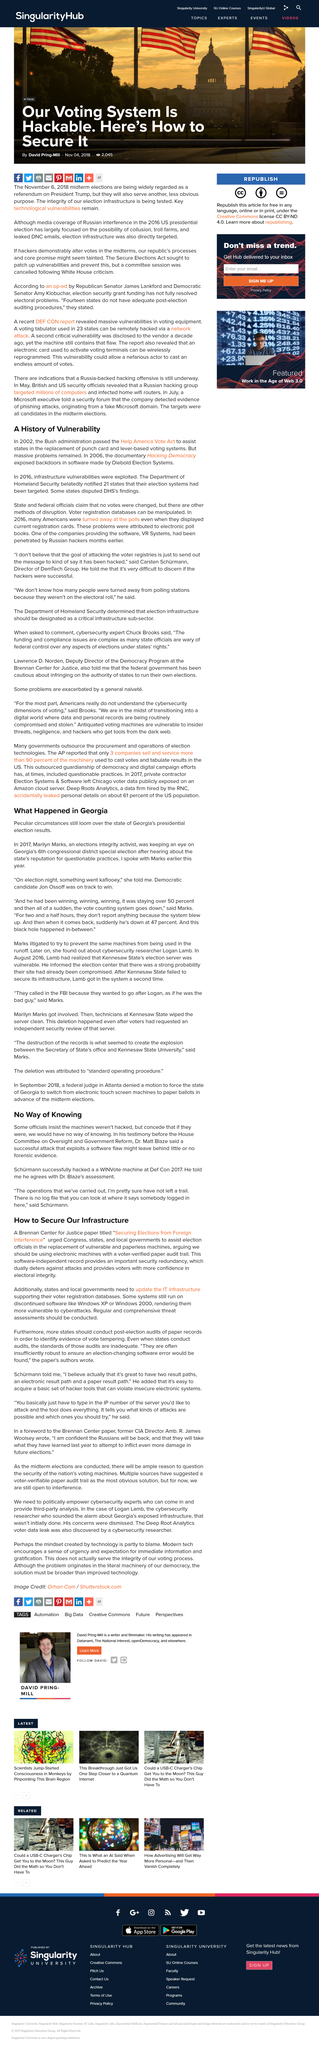Indicate a few pertinent items in this graphic. I, [Your Name], hereby declare that the candidate's name is Job Ossoff and he was running for the state of Georgia in the most recent election. Hacking Democracy, a documentary that explores the issues surrounding electronic voting machines, was released in 2006. Marilyn Marks, an elections integrity activist, was monitoring the district's special election. In the article, two voting software companies, Diebold Election Systems and VR Systems, are mentioned. These companies are responsible for providing electronic voting systems to various counties across the United States. The system blew up, and nothing was reported for 2 and a half hours. 